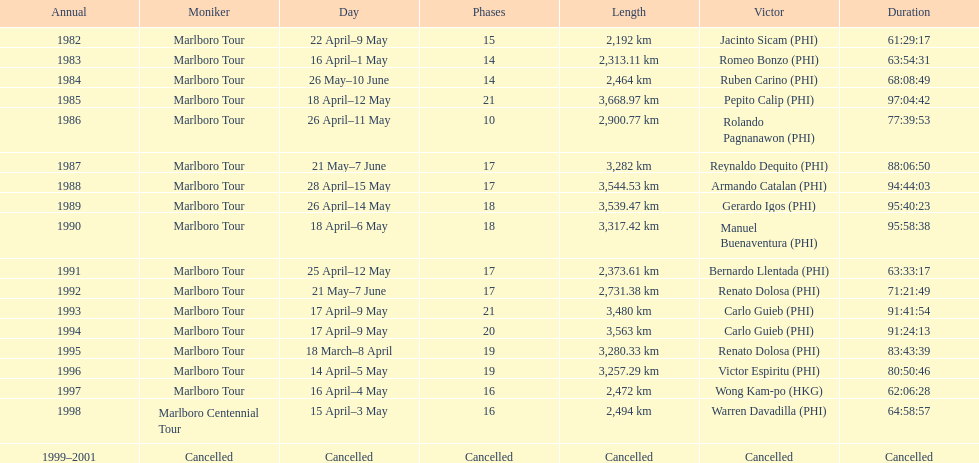Could you parse the entire table as a dict? {'header': ['Annual', 'Moniker', 'Day', 'Phases', 'Length', 'Victor', 'Duration'], 'rows': [['1982', 'Marlboro Tour', '22 April–9 May', '15', '2,192\xa0km', 'Jacinto Sicam\xa0(PHI)', '61:29:17'], ['1983', 'Marlboro Tour', '16 April–1 May', '14', '2,313.11\xa0km', 'Romeo Bonzo\xa0(PHI)', '63:54:31'], ['1984', 'Marlboro Tour', '26 May–10 June', '14', '2,464\xa0km', 'Ruben Carino\xa0(PHI)', '68:08:49'], ['1985', 'Marlboro Tour', '18 April–12 May', '21', '3,668.97\xa0km', 'Pepito Calip\xa0(PHI)', '97:04:42'], ['1986', 'Marlboro Tour', '26 April–11 May', '10', '2,900.77\xa0km', 'Rolando Pagnanawon\xa0(PHI)', '77:39:53'], ['1987', 'Marlboro Tour', '21 May–7 June', '17', '3,282\xa0km', 'Reynaldo Dequito\xa0(PHI)', '88:06:50'], ['1988', 'Marlboro Tour', '28 April–15 May', '17', '3,544.53\xa0km', 'Armando Catalan\xa0(PHI)', '94:44:03'], ['1989', 'Marlboro Tour', '26 April–14 May', '18', '3,539.47\xa0km', 'Gerardo Igos\xa0(PHI)', '95:40:23'], ['1990', 'Marlboro Tour', '18 April–6 May', '18', '3,317.42\xa0km', 'Manuel Buenaventura\xa0(PHI)', '95:58:38'], ['1991', 'Marlboro Tour', '25 April–12 May', '17', '2,373.61\xa0km', 'Bernardo Llentada\xa0(PHI)', '63:33:17'], ['1992', 'Marlboro Tour', '21 May–7 June', '17', '2,731.38\xa0km', 'Renato Dolosa\xa0(PHI)', '71:21:49'], ['1993', 'Marlboro Tour', '17 April–9 May', '21', '3,480\xa0km', 'Carlo Guieb\xa0(PHI)', '91:41:54'], ['1994', 'Marlboro Tour', '17 April–9 May', '20', '3,563\xa0km', 'Carlo Guieb\xa0(PHI)', '91:24:13'], ['1995', 'Marlboro Tour', '18 March–8 April', '19', '3,280.33\xa0km', 'Renato Dolosa\xa0(PHI)', '83:43:39'], ['1996', 'Marlboro Tour', '14 April–5 May', '19', '3,257.29\xa0km', 'Victor Espiritu\xa0(PHI)', '80:50:46'], ['1997', 'Marlboro Tour', '16 April–4 May', '16', '2,472\xa0km', 'Wong Kam-po\xa0(HKG)', '62:06:28'], ['1998', 'Marlboro Centennial Tour', '15 April–3 May', '16', '2,494\xa0km', 'Warren Davadilla\xa0(PHI)', '64:58:57'], ['1999–2001', 'Cancelled', 'Cancelled', 'Cancelled', 'Cancelled', 'Cancelled', 'Cancelled']]} How many stages was the 1982 marlboro tour? 15. 